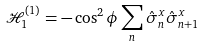<formula> <loc_0><loc_0><loc_500><loc_500>\mathcal { H } _ { 1 } ^ { ( 1 ) } = - \cos ^ { 2 } \phi \sum _ { n } \hat { \sigma } ^ { x } _ { n } \hat { \sigma } ^ { x } _ { n + 1 }</formula> 